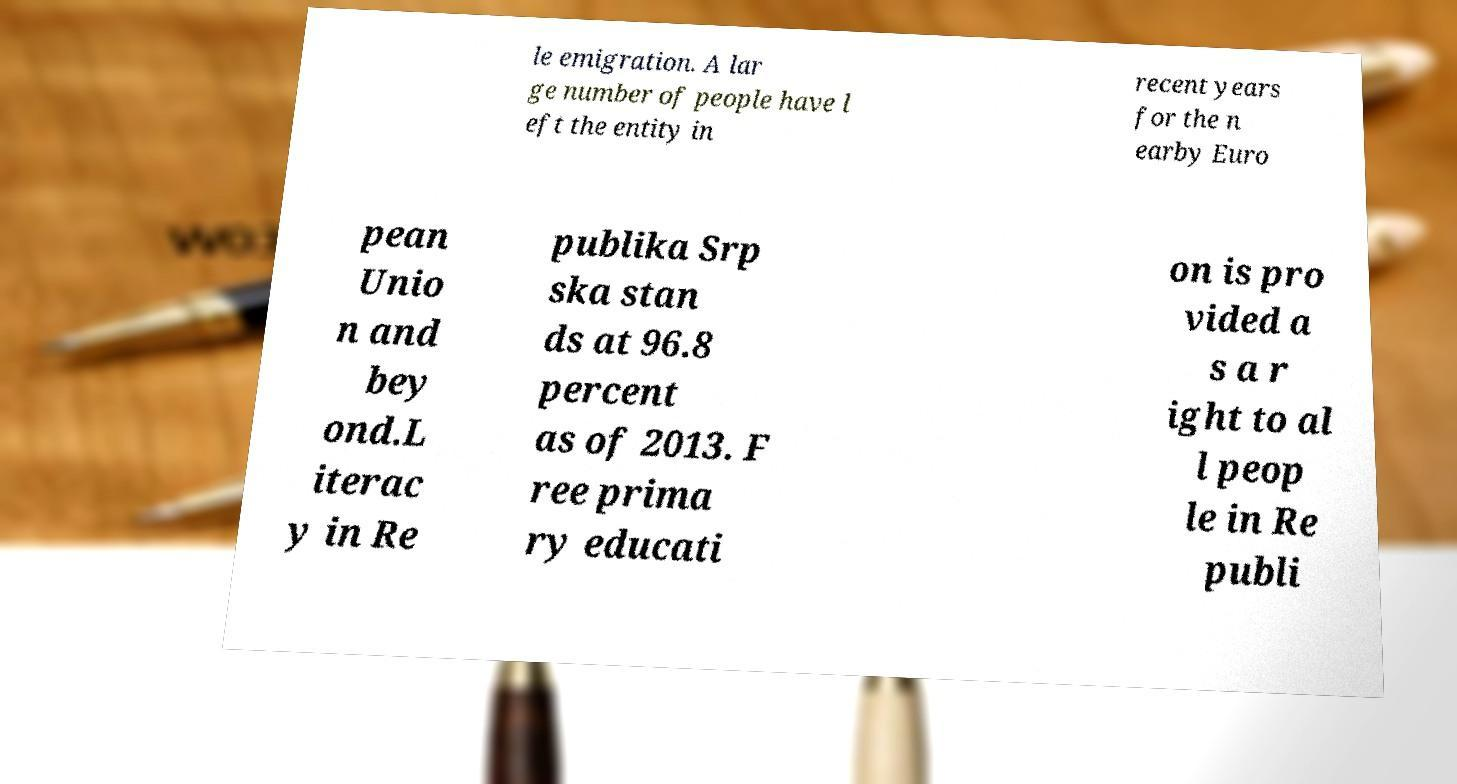Can you accurately transcribe the text from the provided image for me? le emigration. A lar ge number of people have l eft the entity in recent years for the n earby Euro pean Unio n and bey ond.L iterac y in Re publika Srp ska stan ds at 96.8 percent as of 2013. F ree prima ry educati on is pro vided a s a r ight to al l peop le in Re publi 